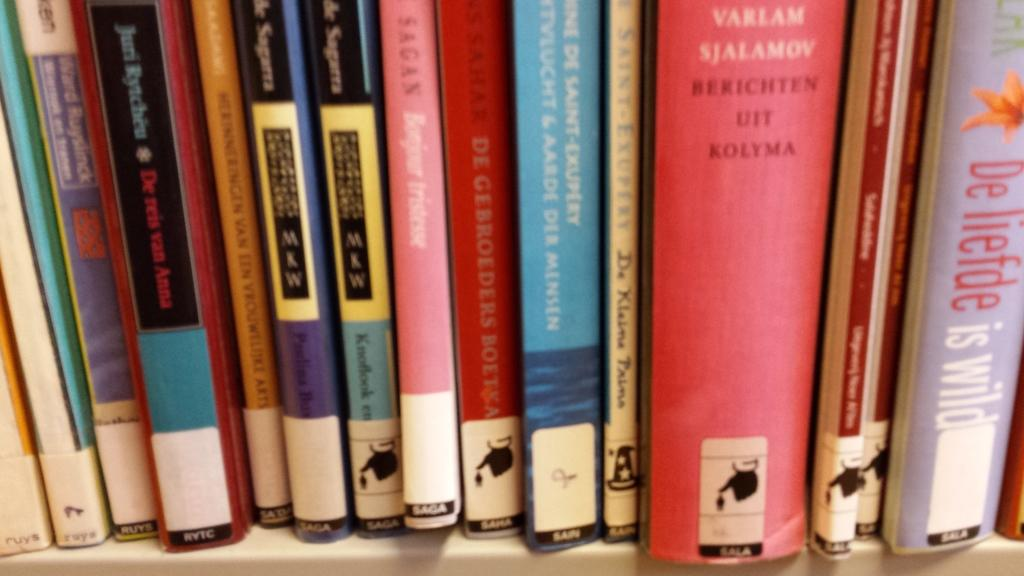<image>
Relay a brief, clear account of the picture shown. A pink spine of a book authored by Varlam Sjalamov. 